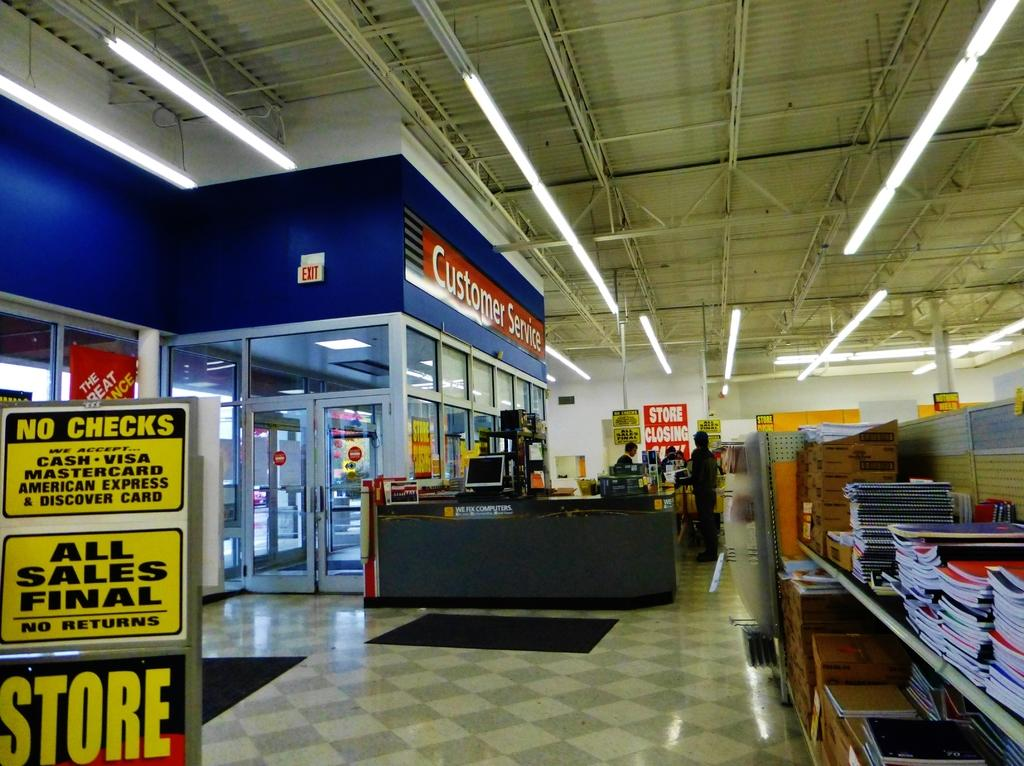<image>
Give a short and clear explanation of the subsequent image. Store front that has the words Customer Service on top. 